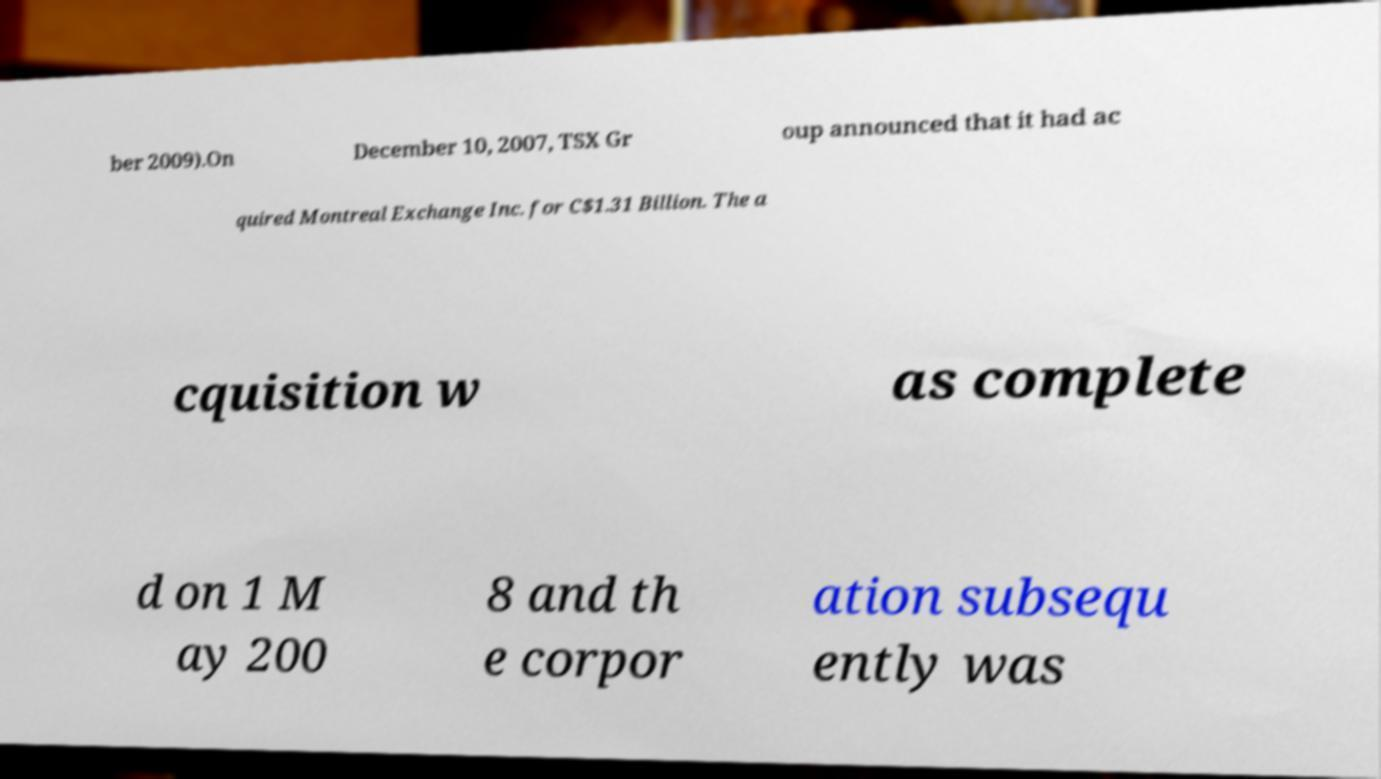Could you extract and type out the text from this image? ber 2009).On December 10, 2007, TSX Gr oup announced that it had ac quired Montreal Exchange Inc. for C$1.31 Billion. The a cquisition w as complete d on 1 M ay 200 8 and th e corpor ation subsequ ently was 